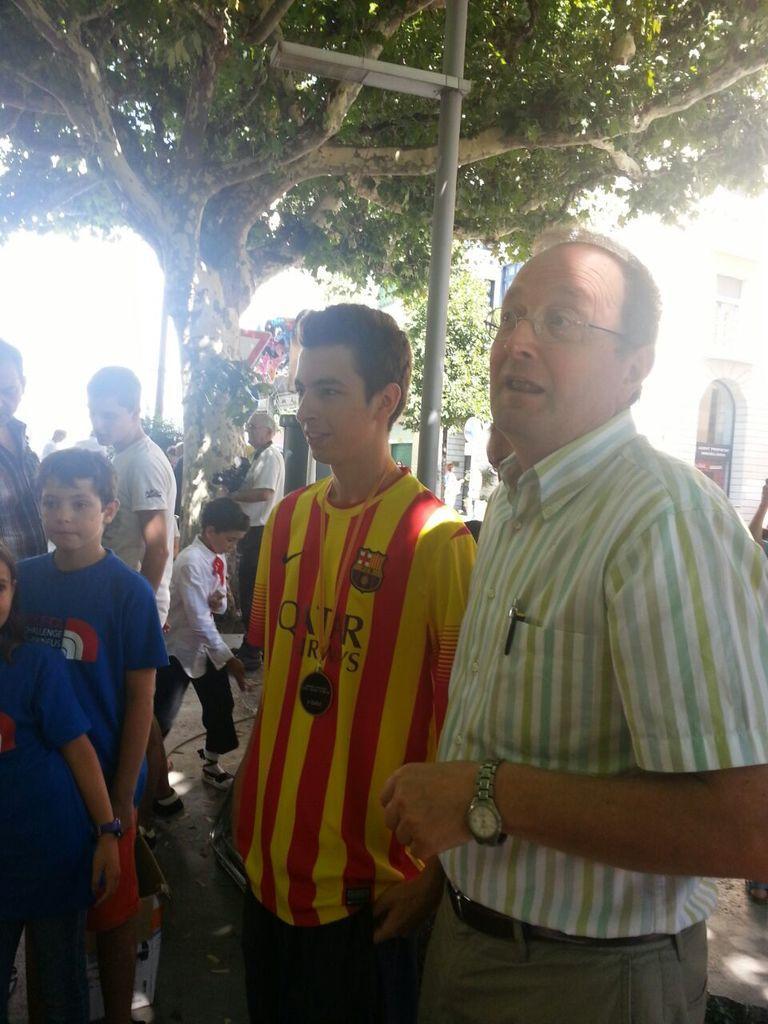Could you give a brief overview of what you see in this image? In this image I can see a person wearing white, green and blue colored dress is standing, another person wearing red and yellow colored dress is standing and few other persons are standing on the ground. In the background I can see few persons standing, a tree, a pole and light to the pole and a building which is white in color. 